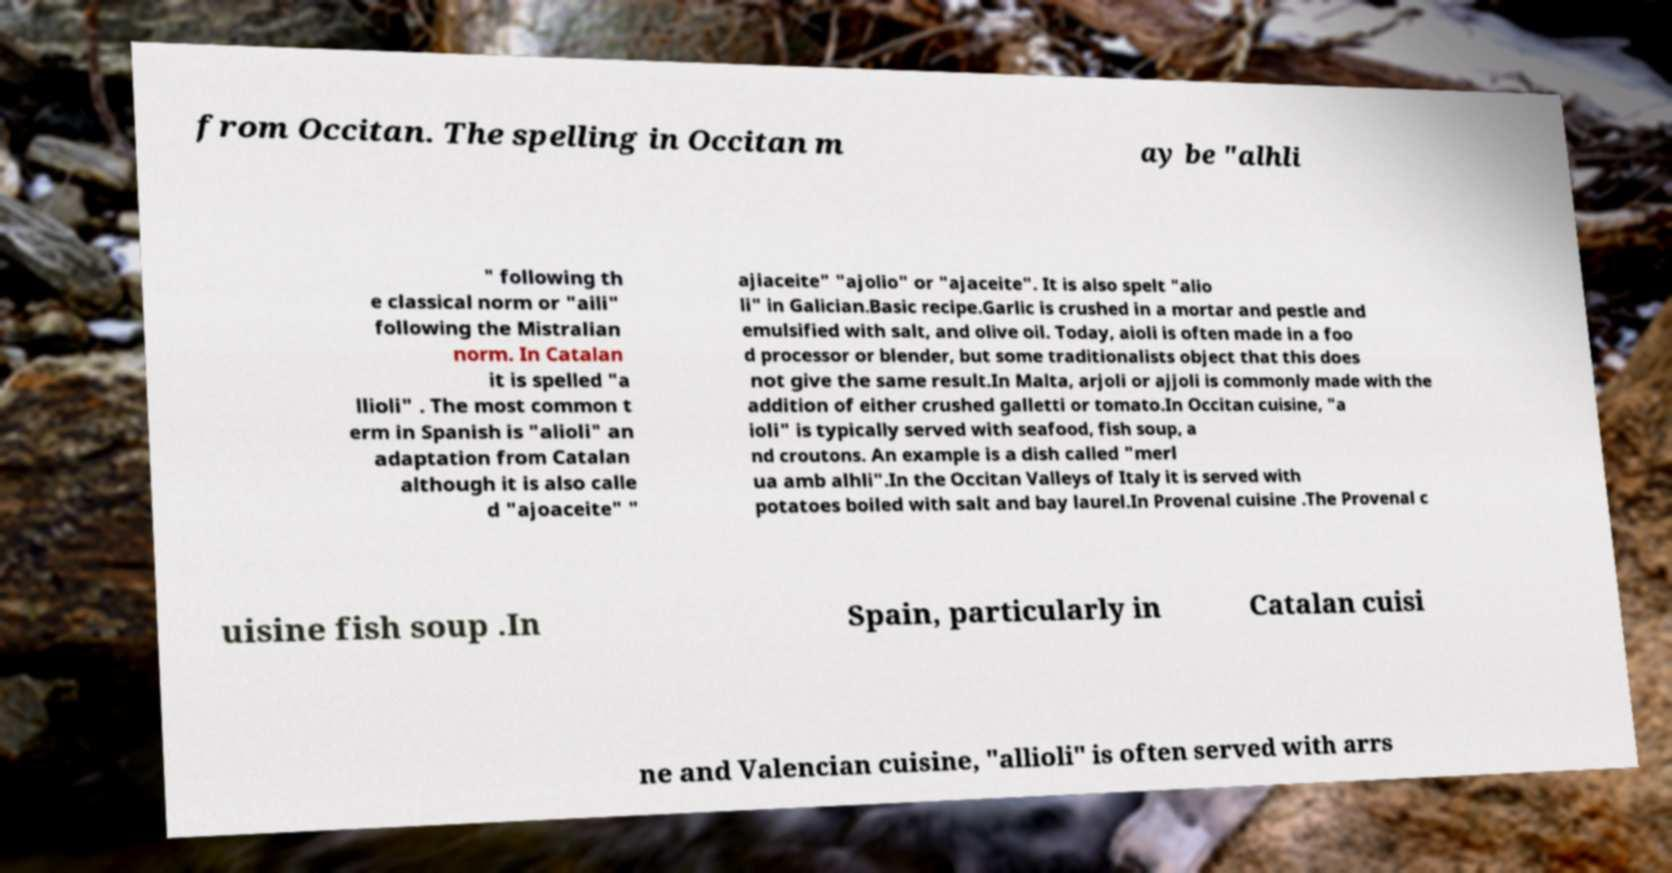For documentation purposes, I need the text within this image transcribed. Could you provide that? from Occitan. The spelling in Occitan m ay be "alhli " following th e classical norm or "aili" following the Mistralian norm. In Catalan it is spelled "a llioli" . The most common t erm in Spanish is "alioli" an adaptation from Catalan although it is also calle d "ajoaceite" " ajiaceite" "ajolio" or "ajaceite". It is also spelt "alio li" in Galician.Basic recipe.Garlic is crushed in a mortar and pestle and emulsified with salt, and olive oil. Today, aioli is often made in a foo d processor or blender, but some traditionalists object that this does not give the same result.In Malta, arjoli or ajjoli is commonly made with the addition of either crushed galletti or tomato.In Occitan cuisine, "a ioli" is typically served with seafood, fish soup, a nd croutons. An example is a dish called "merl ua amb alhli".In the Occitan Valleys of Italy it is served with potatoes boiled with salt and bay laurel.In Provenal cuisine .The Provenal c uisine fish soup .In Spain, particularly in Catalan cuisi ne and Valencian cuisine, "allioli" is often served with arrs 